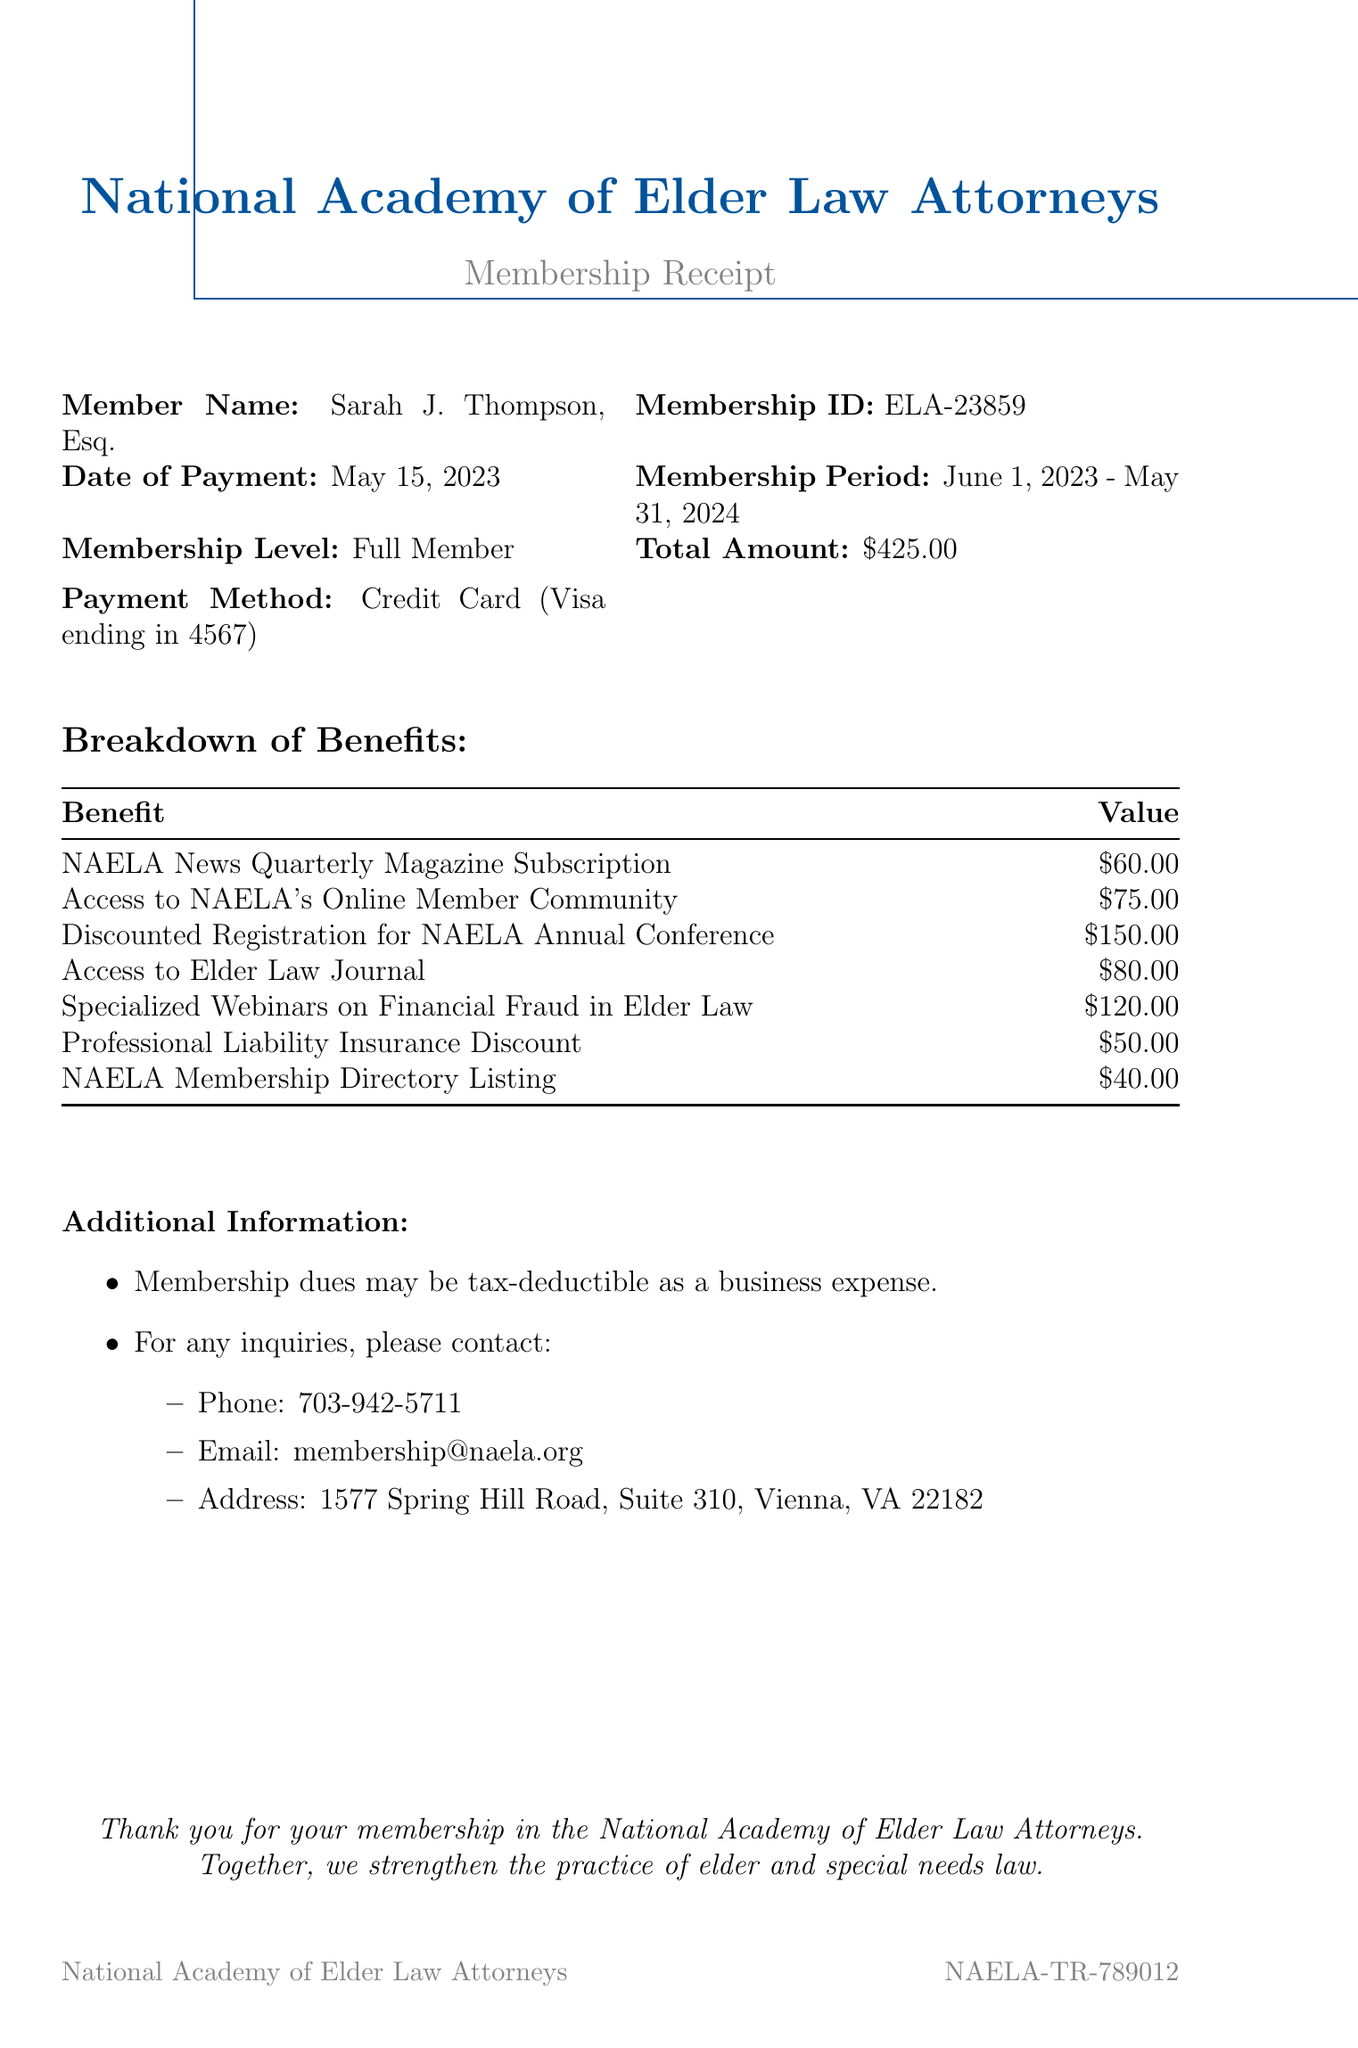What is the name of the member? The member's name is explicitly stated in the document as Sarah J. Thompson, Esq.
Answer: Sarah J. Thompson, Esq What is the membership ID? The document provides a specific membership ID for the member, which is ELA-23859.
Answer: ELA-23859 When was the payment made? The date of payment is clearly indicated in the document as May 15, 2023.
Answer: May 15, 2023 What is the total amount paid for the membership? The total amount of the payment is listed in the document as $425.00.
Answer: $425.00 What is one benefit of membership? Multiple benefits are listed, and one example is the NAELA News Quarterly Magazine Subscription.
Answer: NAELA News Quarterly Magazine Subscription How much is the discount for the NAELA Annual Conference? The amount for discounted registration for the conference is provided in the document as $150.00.
Answer: $150.00 What is the membership period? The membership period is specified in the document as June 1, 2023 - May 31, 2024.
Answer: June 1, 2023 - May 31, 2024 Is the membership dues tax-deductible? The document states that membership dues may be tax-deductible, which indicates the possibility of deduction as a business expense.
Answer: Yes What type of payment method was used? The payment method is explicitly described in the document as Credit Card (Visa ending in 4567).
Answer: Credit Card (Visa ending in 4567) How can someone contact NAELA for inquiries? Contact information is provided in the document, which includes a phone number, email, and address for inquiries.
Answer: Phone: 703-942-5711, Email: membership@naela.org, Address: 1577 Spring Hill Road, Suite 310, Vienna, VA 22182 